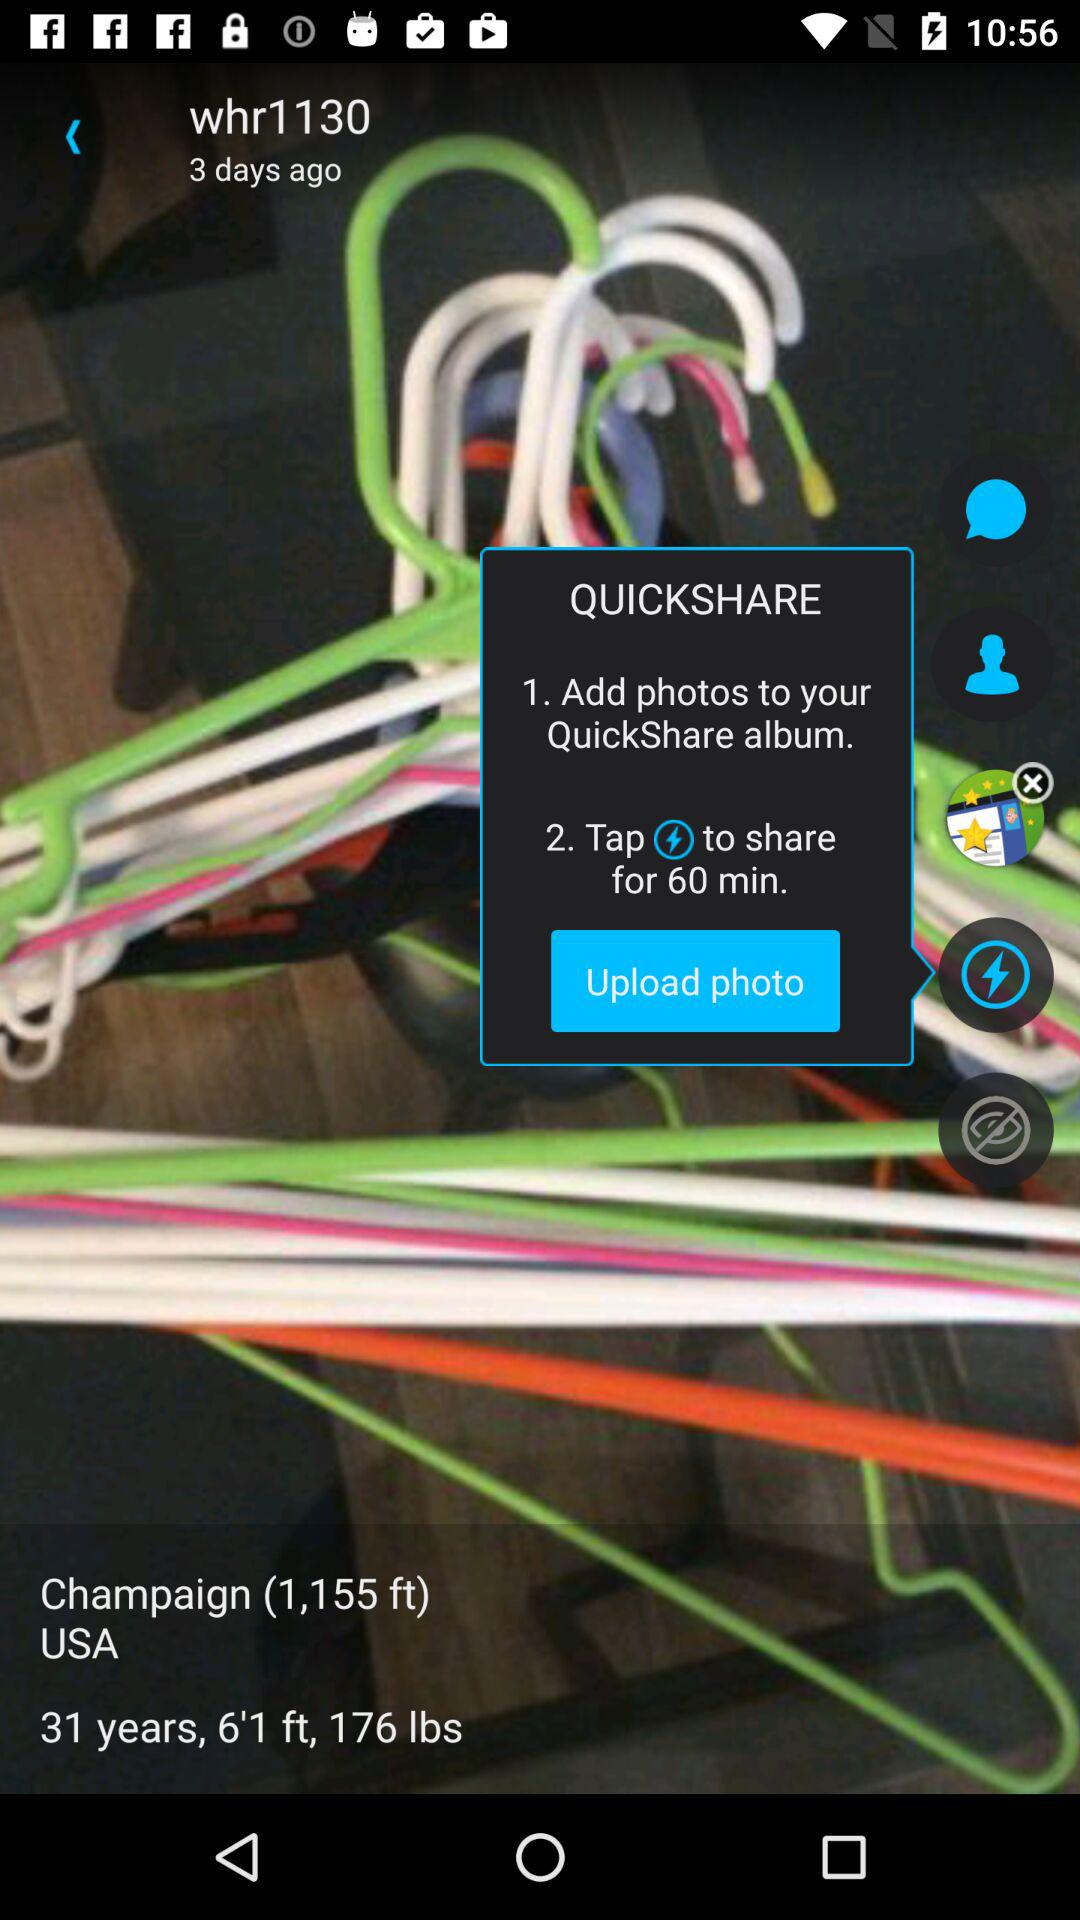What is application name?
When the provided information is insufficient, respond with <no answer>. <no answer> 